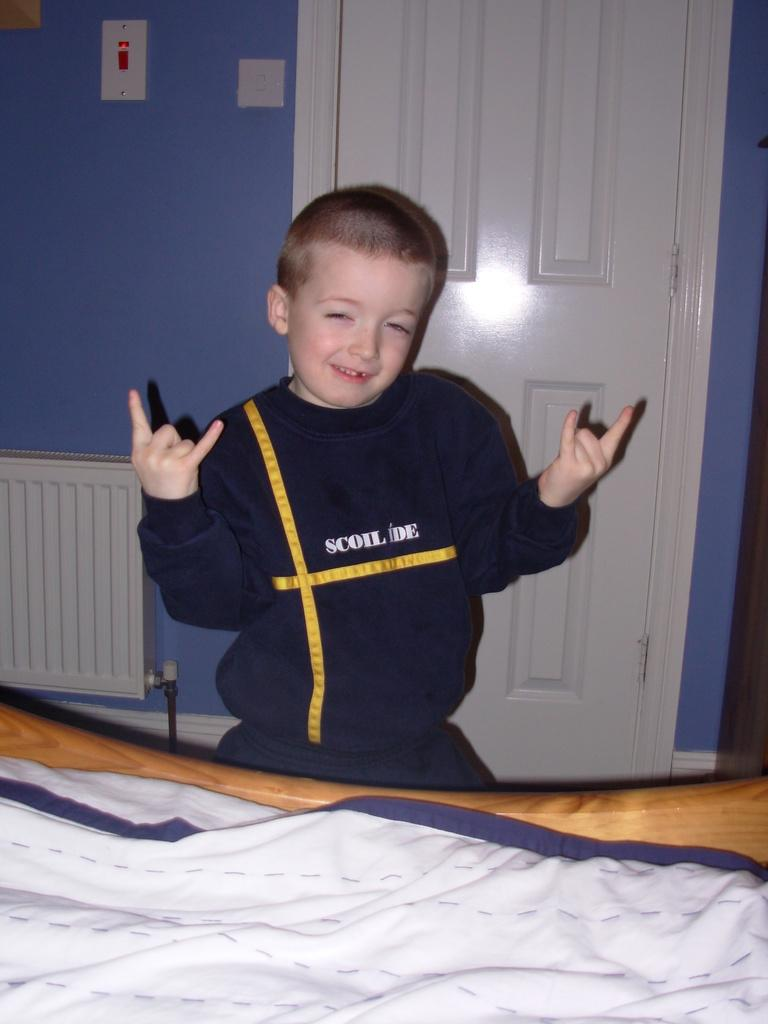<image>
Create a compact narrative representing the image presented. A boy in a Scoil Ide sweatshirt throws up hand horns. 